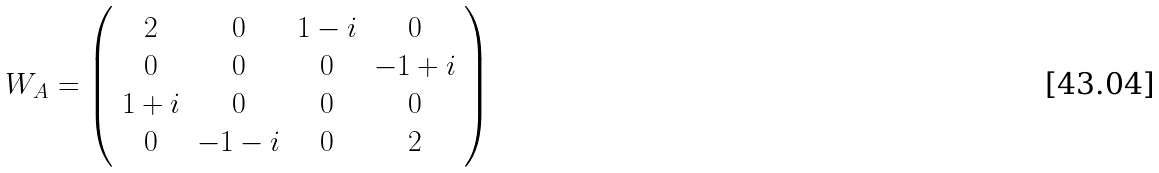<formula> <loc_0><loc_0><loc_500><loc_500>W _ { A } = \left ( \begin{array} { c c c c } 2 & 0 & 1 - i & 0 \\ 0 & 0 & 0 & - 1 + i \\ 1 + i & 0 & 0 & 0 \\ 0 & - 1 - i & 0 & 2 \\ \end{array} \right )</formula> 